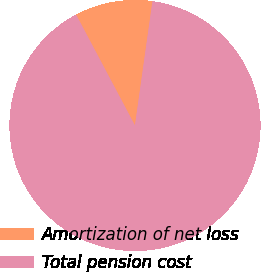Convert chart. <chart><loc_0><loc_0><loc_500><loc_500><pie_chart><fcel>Amortization of net loss<fcel>Total pension cost<nl><fcel>10.0%<fcel>90.0%<nl></chart> 